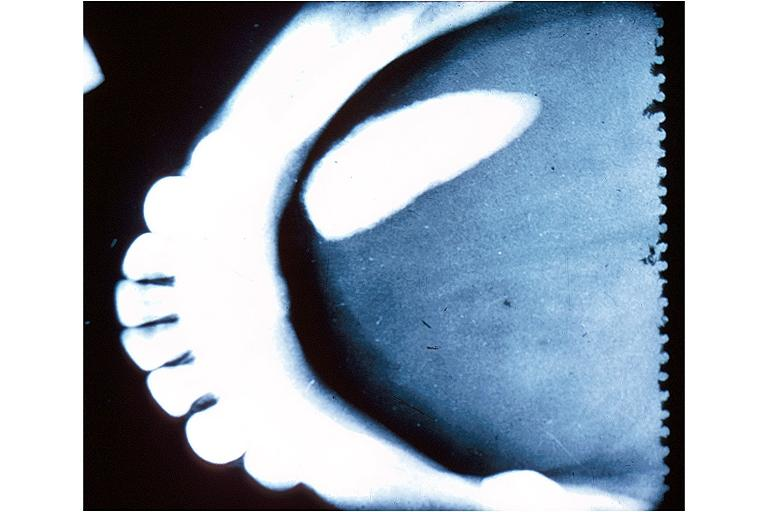does this image show sialolith?
Answer the question using a single word or phrase. Yes 